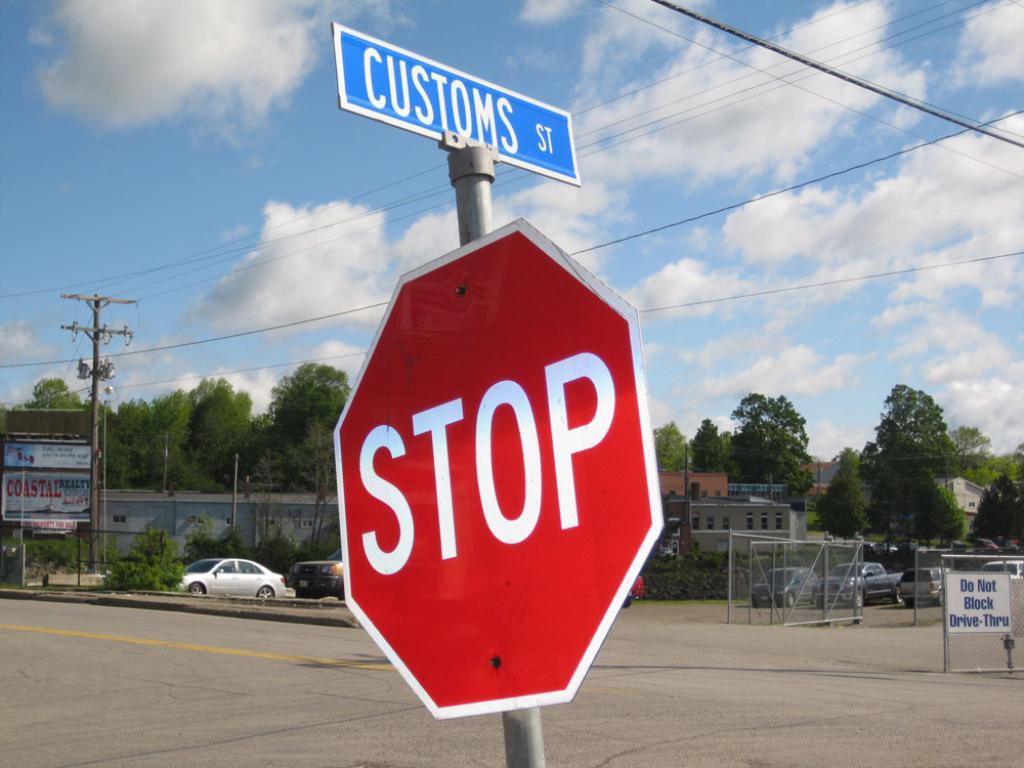<image>
Render a clear and concise summary of the photo. A stop sign is visible on Customs Street. 